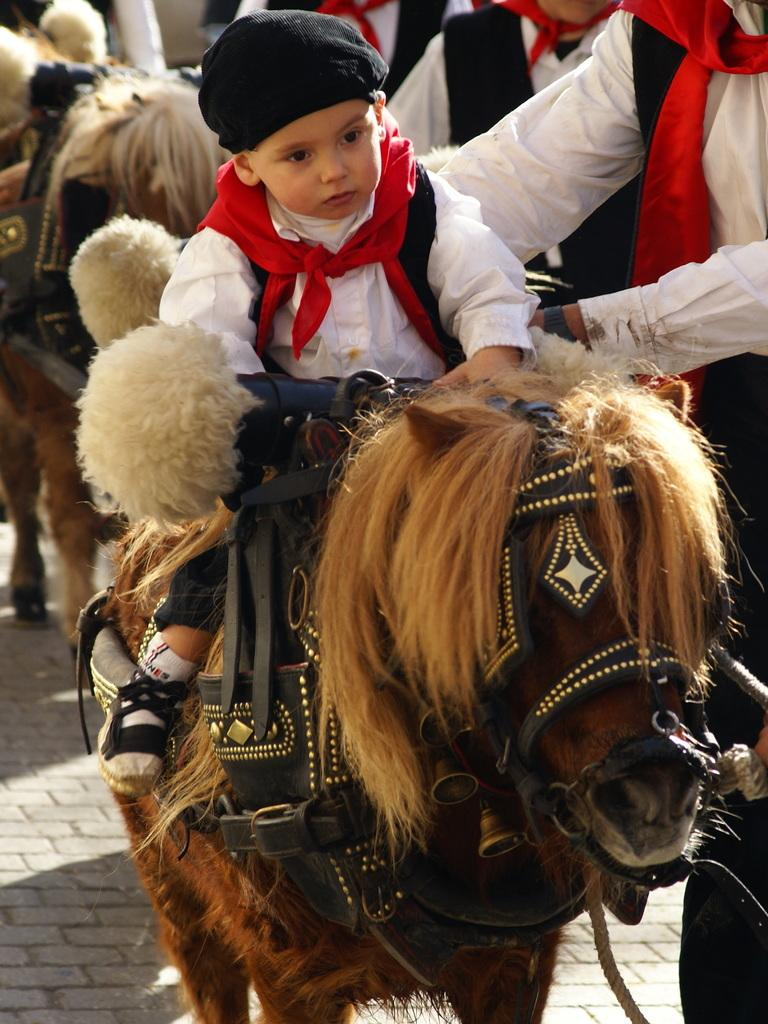Who is the main subject in the image? There is a boy in the image. What is the boy doing in the image? The boy is sitting on a horse. What is the surface beneath the boy and the horse? There is a floor in the image. Are there any other people in the image besides the boy? Yes, there are people standing on the floor. What type of memory does the boy have in the image? There is no mention of a memory in the image; it simply shows a boy sitting on a horse with people standing on the floor. How many planes can be seen in the image? There are no planes present in the image. 